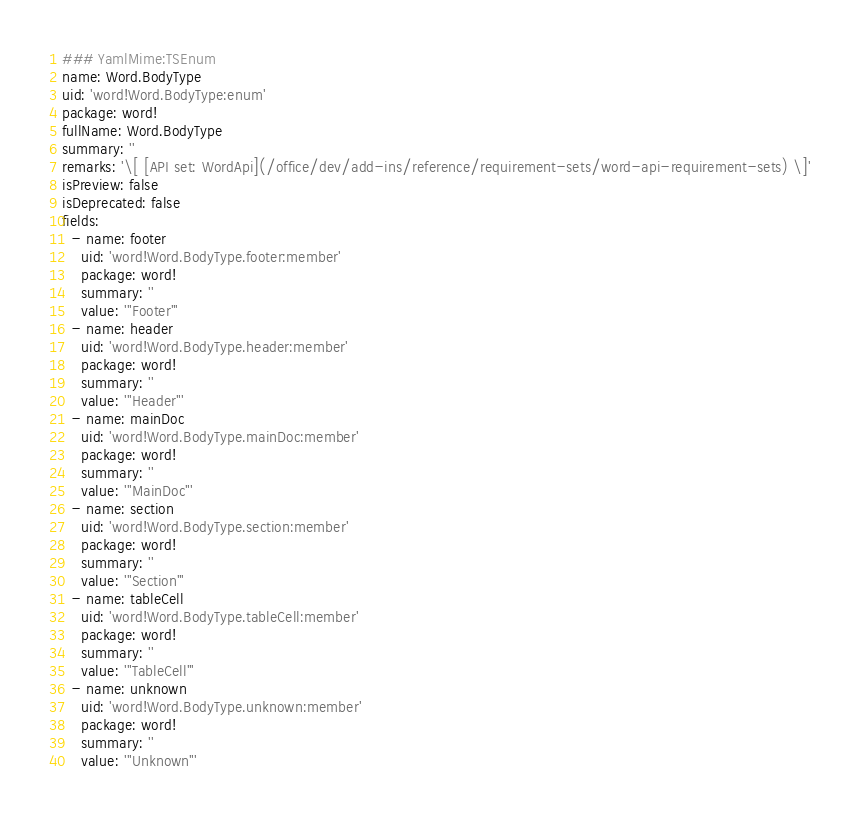Convert code to text. <code><loc_0><loc_0><loc_500><loc_500><_YAML_>### YamlMime:TSEnum
name: Word.BodyType
uid: 'word!Word.BodyType:enum'
package: word!
fullName: Word.BodyType
summary: ''
remarks: '\[ [API set: WordApi](/office/dev/add-ins/reference/requirement-sets/word-api-requirement-sets) \]'
isPreview: false
isDeprecated: false
fields:
  - name: footer
    uid: 'word!Word.BodyType.footer:member'
    package: word!
    summary: ''
    value: '"Footer"'
  - name: header
    uid: 'word!Word.BodyType.header:member'
    package: word!
    summary: ''
    value: '"Header"'
  - name: mainDoc
    uid: 'word!Word.BodyType.mainDoc:member'
    package: word!
    summary: ''
    value: '"MainDoc"'
  - name: section
    uid: 'word!Word.BodyType.section:member'
    package: word!
    summary: ''
    value: '"Section"'
  - name: tableCell
    uid: 'word!Word.BodyType.tableCell:member'
    package: word!
    summary: ''
    value: '"TableCell"'
  - name: unknown
    uid: 'word!Word.BodyType.unknown:member'
    package: word!
    summary: ''
    value: '"Unknown"'
</code> 